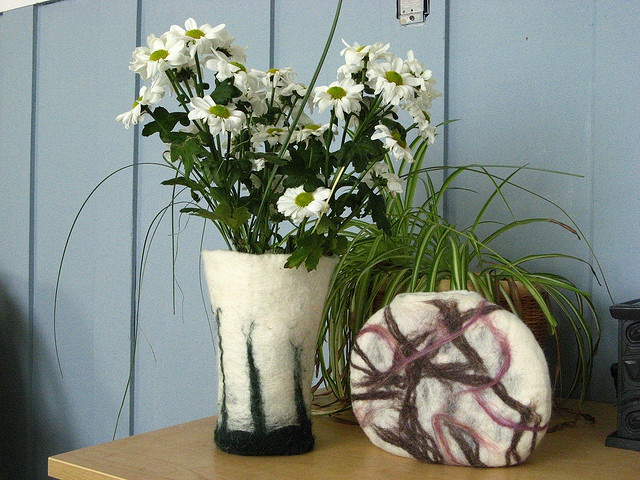Describe the objects in this image and their specific colors. I can see potted plant in ivory, black, gray, darkgreen, and darkgray tones, vase in ivory, beige, black, and darkgray tones, and dining table in ivory, tan, olive, and gray tones in this image. 